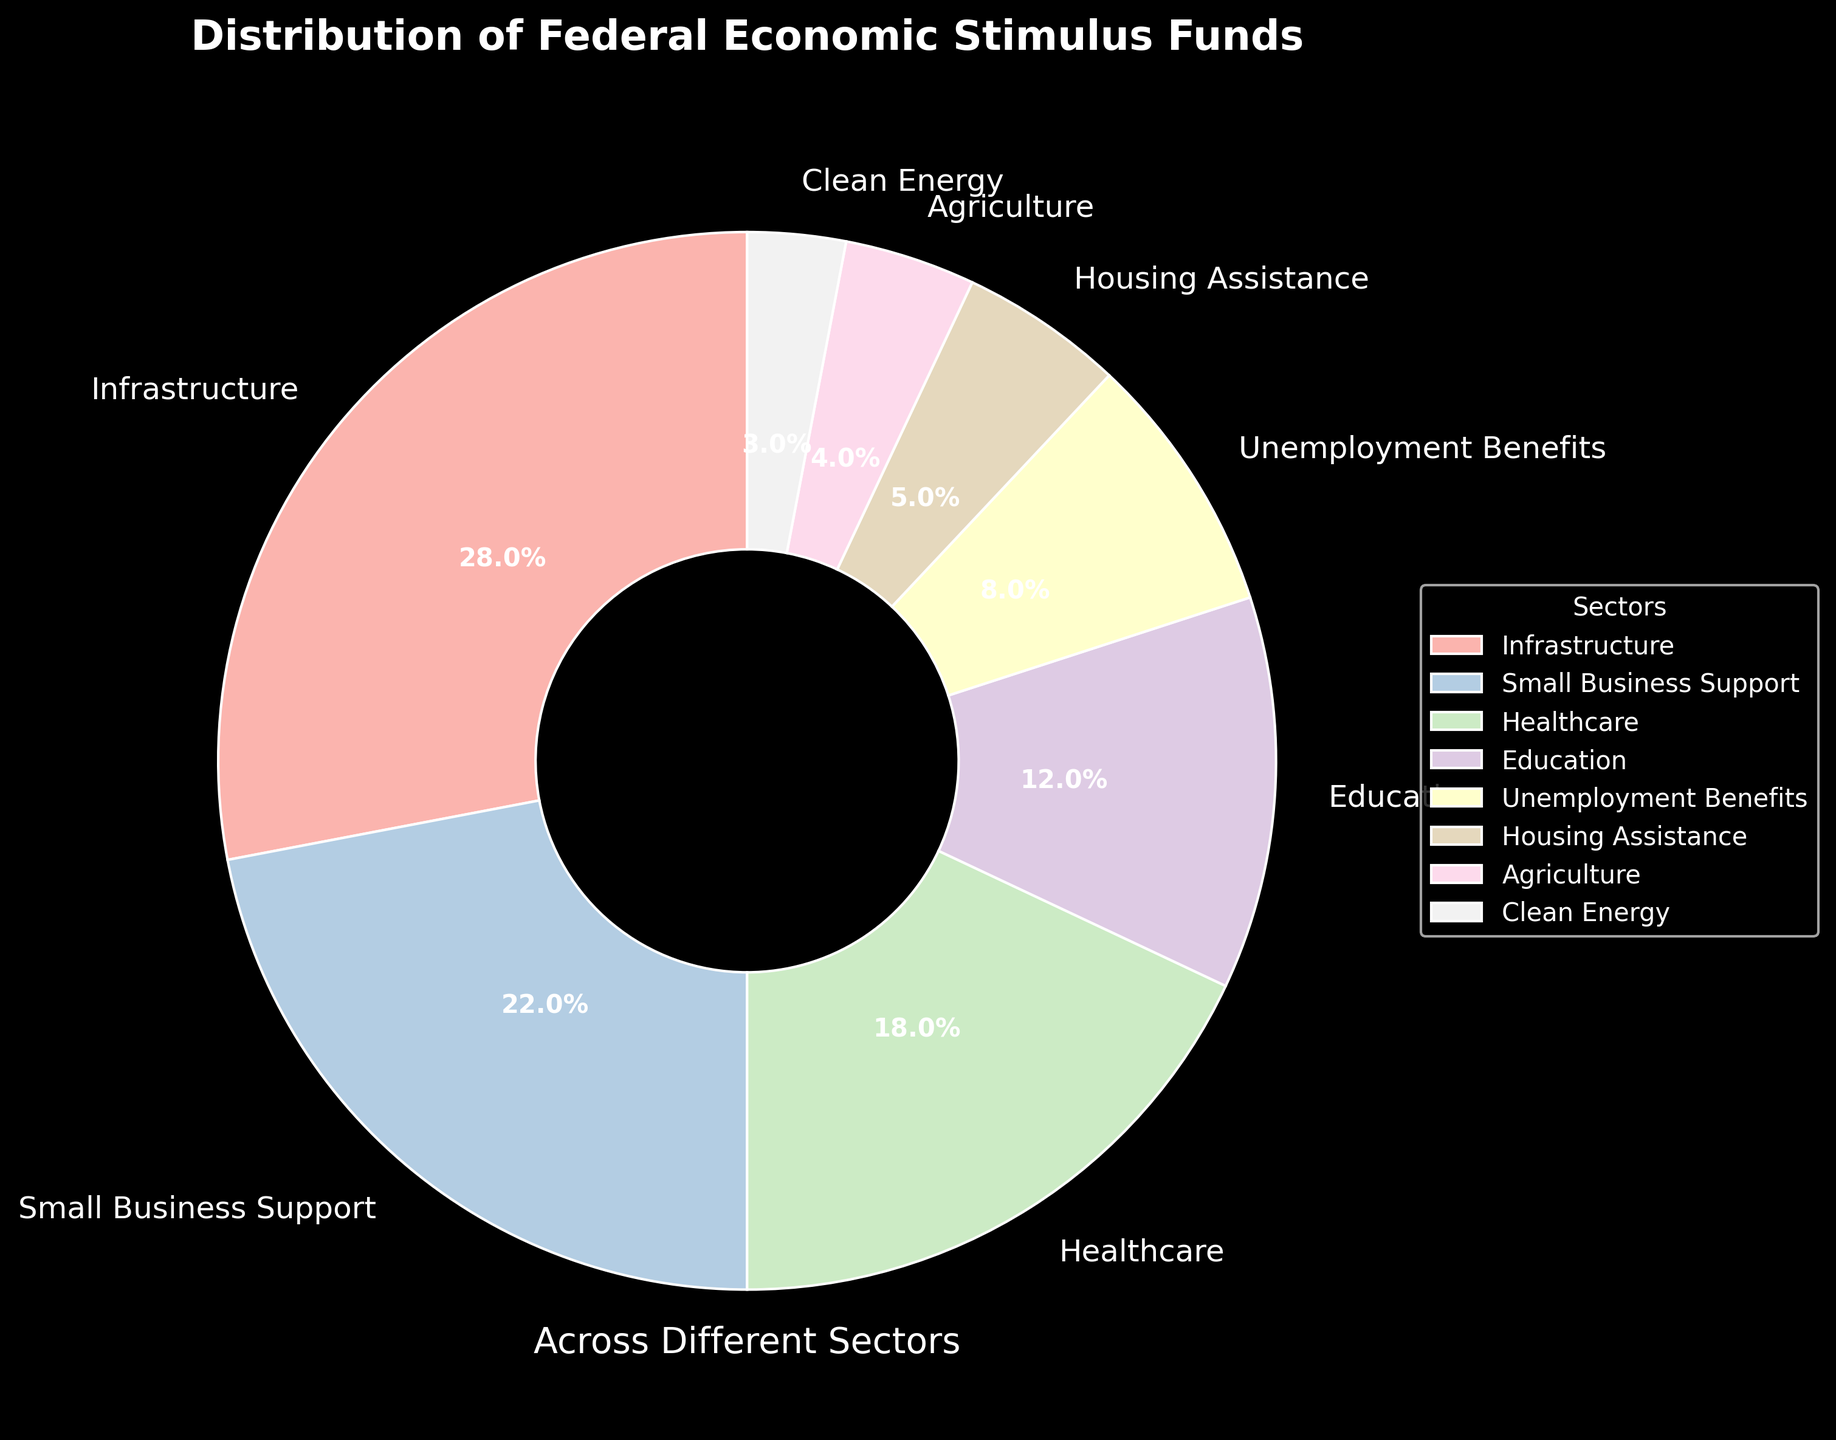What sector receives the highest percentage of federal economic stimulus funds? By looking at the pie chart, the largest wedge corresponds to Infrastructure, which occupies the largest area compared to other sectors. This indicates it receives the highest percentage.
Answer: Infrastructure Which sector receives the least amount of federal economic stimulus funds? The smallest wedge on the pie chart is labeled as Clean Energy. This visually represents the sector with the lowest percentage allocation.
Answer: Clean Energy How much more funding percentage does Small Business Support receive compared to Housing Assistance? From the pie chart, Small Business Support is at 22% and Housing Assistance at 5%. Subtracting these, 22% - 5% equals 17%.
Answer: 17% What is the combined percentage of federal economic stimulus funds for Education and Healthcare? According to the pie chart, Education is at 12% and Healthcare at 18%. Adding these together, 12% + 18% equals 30%.
Answer: 30% How does the funding for Unemployment Benefits compare to Housing Assistance? Unemployment Benefits have a wedge size representing 8%, whereas Housing Assistance shows 5%. Thus, Unemployment Benefits have a larger share.
Answer: Unemployment Benefits have more Which sector receives precisely three times the allocation of another sector, and what are those sectors? Infrastructure receives 28%, and Agriculture receives 4%. When you compare them, 28% is exactly three times 4%.
Answer: Infrastructure and Agriculture What is the difference in funding percentage between Healthcare and Clean Energy? According to the pie chart, Healthcare receives 18% and Clean Energy receives 3%. Subtracting these, 18% - 3% equals 15%.
Answer: 15% Which sectors combined receive more than half of the total federal economic stimulus funds? Adding the percentages from the largest sectors: Infrastructure (28%), Small Business Support (22%), and Healthcare (18%) gives 28% + 22% + 18% = 68%. This is more than half of the total.
Answer: Infrastructure, Small Business Support, Healthcare If the percentages of Unemployment Benefits and Agriculture are combined, do they surpass the percentage allocated to Education? Unemployment Benefits are at 8% and Agriculture at 4%. Combining them gives 8% + 4% = 12%, which is equal to Education’s allocation at 12%.
Answer: No, they are equal Based on the visual, which sector has the largest contribution from pastel colors that are more towards the orange shade? Judging by the color scheme of the wedges, which use pastel tones, Infrastructure exhibits a notably larger and more orange-hued section.
Answer: Infrastructure 